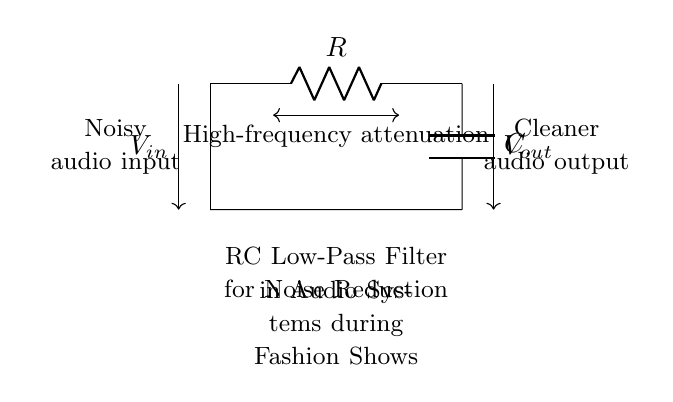What components make up this circuit? The circuit consists of a resistor and a capacitor, as indicated by the symbols R and C in the diagram.
Answer: Resistor and Capacitor What type of filter is shown in the circuit? The circuit is designed as a low-pass filter, which allows low-frequency signals to pass while attenuating higher frequencies, as denoted by the 'RC Low-Pass Filter' label.
Answer: Low-pass filter What effect does this circuit have on high frequencies? The circuit attenuates high frequencies, meaning it reduces the amplitude of these signals, which is noted by the label indicating 'High-frequency attenuation.'
Answer: Attenuation What is the function of the capacitor in this circuit? The capacitor functions to store charge and, combined with the resistor, determines the cutoff frequency of the low-pass filter, thus affecting noise reduction capability.
Answer: Noise reduction What is the output type of this circuit? The output is cleaner audio output, designed to diminish noise from the noisy audio input, as described in the labeling of the circuit.
Answer: Cleaner audio output What determines the cutoff frequency of this RC filter? The cutoff frequency is determined by the values of the resistor and capacitor according to the formula f_c = 1 / (2πRC), indicating the frequency at which the output power is reduced to half of the input power.
Answer: R and C values How does this circuit benefit audio systems during fashion shows? This circuit benefits audio systems by reducing unwanted noise, providing clearer sound during the event, which is crucial for maintaining brand image in fashion shows.
Answer: Clearer sound 